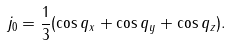<formula> <loc_0><loc_0><loc_500><loc_500>j _ { 0 } = \frac { 1 } { 3 } ( \cos { q _ { x } } + \cos { q _ { y } } + \cos { q _ { z } } ) .</formula> 